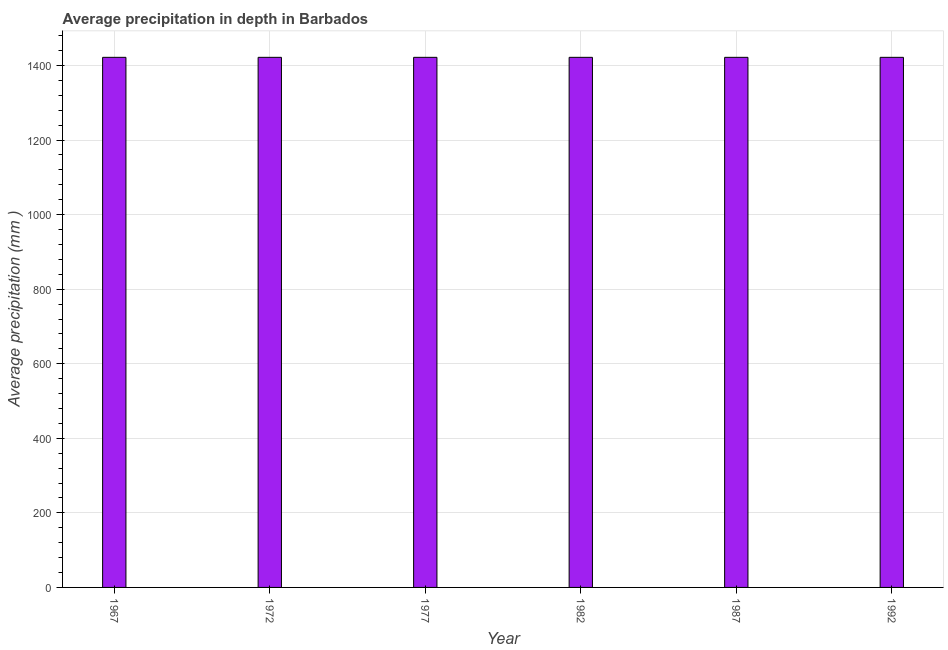What is the title of the graph?
Offer a terse response. Average precipitation in depth in Barbados. What is the label or title of the X-axis?
Offer a very short reply. Year. What is the label or title of the Y-axis?
Your response must be concise. Average precipitation (mm ). What is the average precipitation in depth in 1982?
Your response must be concise. 1422. Across all years, what is the maximum average precipitation in depth?
Keep it short and to the point. 1422. Across all years, what is the minimum average precipitation in depth?
Provide a succinct answer. 1422. In which year was the average precipitation in depth maximum?
Offer a very short reply. 1967. In which year was the average precipitation in depth minimum?
Keep it short and to the point. 1967. What is the sum of the average precipitation in depth?
Your answer should be compact. 8532. What is the difference between the average precipitation in depth in 1967 and 1987?
Give a very brief answer. 0. What is the average average precipitation in depth per year?
Make the answer very short. 1422. What is the median average precipitation in depth?
Provide a short and direct response. 1422. What is the ratio of the average precipitation in depth in 1972 to that in 1992?
Offer a very short reply. 1. Is the average precipitation in depth in 1977 less than that in 1982?
Offer a very short reply. No. Is the difference between the average precipitation in depth in 1967 and 1982 greater than the difference between any two years?
Offer a very short reply. Yes. What is the difference between the highest and the second highest average precipitation in depth?
Ensure brevity in your answer.  0. What is the difference between the highest and the lowest average precipitation in depth?
Your answer should be compact. 0. How many bars are there?
Keep it short and to the point. 6. Are all the bars in the graph horizontal?
Provide a short and direct response. No. How many years are there in the graph?
Ensure brevity in your answer.  6. What is the difference between two consecutive major ticks on the Y-axis?
Make the answer very short. 200. Are the values on the major ticks of Y-axis written in scientific E-notation?
Provide a succinct answer. No. What is the Average precipitation (mm ) of 1967?
Provide a succinct answer. 1422. What is the Average precipitation (mm ) in 1972?
Offer a very short reply. 1422. What is the Average precipitation (mm ) of 1977?
Offer a terse response. 1422. What is the Average precipitation (mm ) in 1982?
Make the answer very short. 1422. What is the Average precipitation (mm ) of 1987?
Make the answer very short. 1422. What is the Average precipitation (mm ) in 1992?
Give a very brief answer. 1422. What is the difference between the Average precipitation (mm ) in 1967 and 1982?
Keep it short and to the point. 0. What is the difference between the Average precipitation (mm ) in 1967 and 1992?
Offer a very short reply. 0. What is the difference between the Average precipitation (mm ) in 1972 and 1977?
Your answer should be compact. 0. What is the difference between the Average precipitation (mm ) in 1972 and 1982?
Your answer should be compact. 0. What is the difference between the Average precipitation (mm ) in 1977 and 1982?
Your answer should be compact. 0. What is the difference between the Average precipitation (mm ) in 1977 and 1987?
Ensure brevity in your answer.  0. What is the difference between the Average precipitation (mm ) in 1987 and 1992?
Keep it short and to the point. 0. What is the ratio of the Average precipitation (mm ) in 1967 to that in 1977?
Offer a very short reply. 1. What is the ratio of the Average precipitation (mm ) in 1967 to that in 1982?
Your answer should be compact. 1. What is the ratio of the Average precipitation (mm ) in 1967 to that in 1992?
Your answer should be very brief. 1. What is the ratio of the Average precipitation (mm ) in 1972 to that in 1982?
Provide a succinct answer. 1. What is the ratio of the Average precipitation (mm ) in 1977 to that in 1982?
Keep it short and to the point. 1. What is the ratio of the Average precipitation (mm ) in 1977 to that in 1987?
Your response must be concise. 1. What is the ratio of the Average precipitation (mm ) in 1977 to that in 1992?
Your answer should be compact. 1. What is the ratio of the Average precipitation (mm ) in 1982 to that in 1992?
Ensure brevity in your answer.  1. 